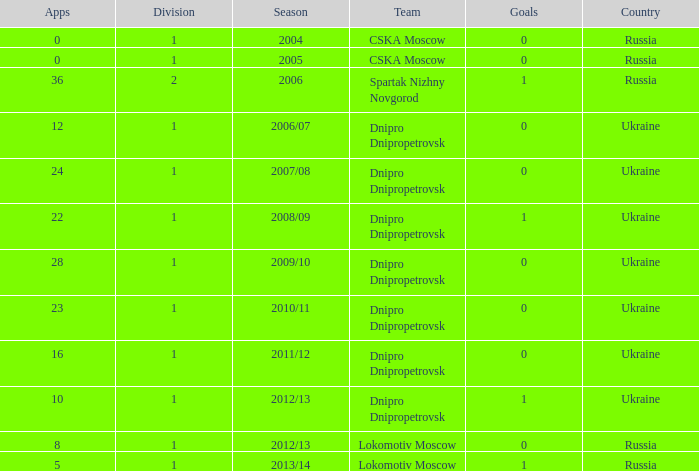What division was Ukraine in 2006/07? 1.0. 